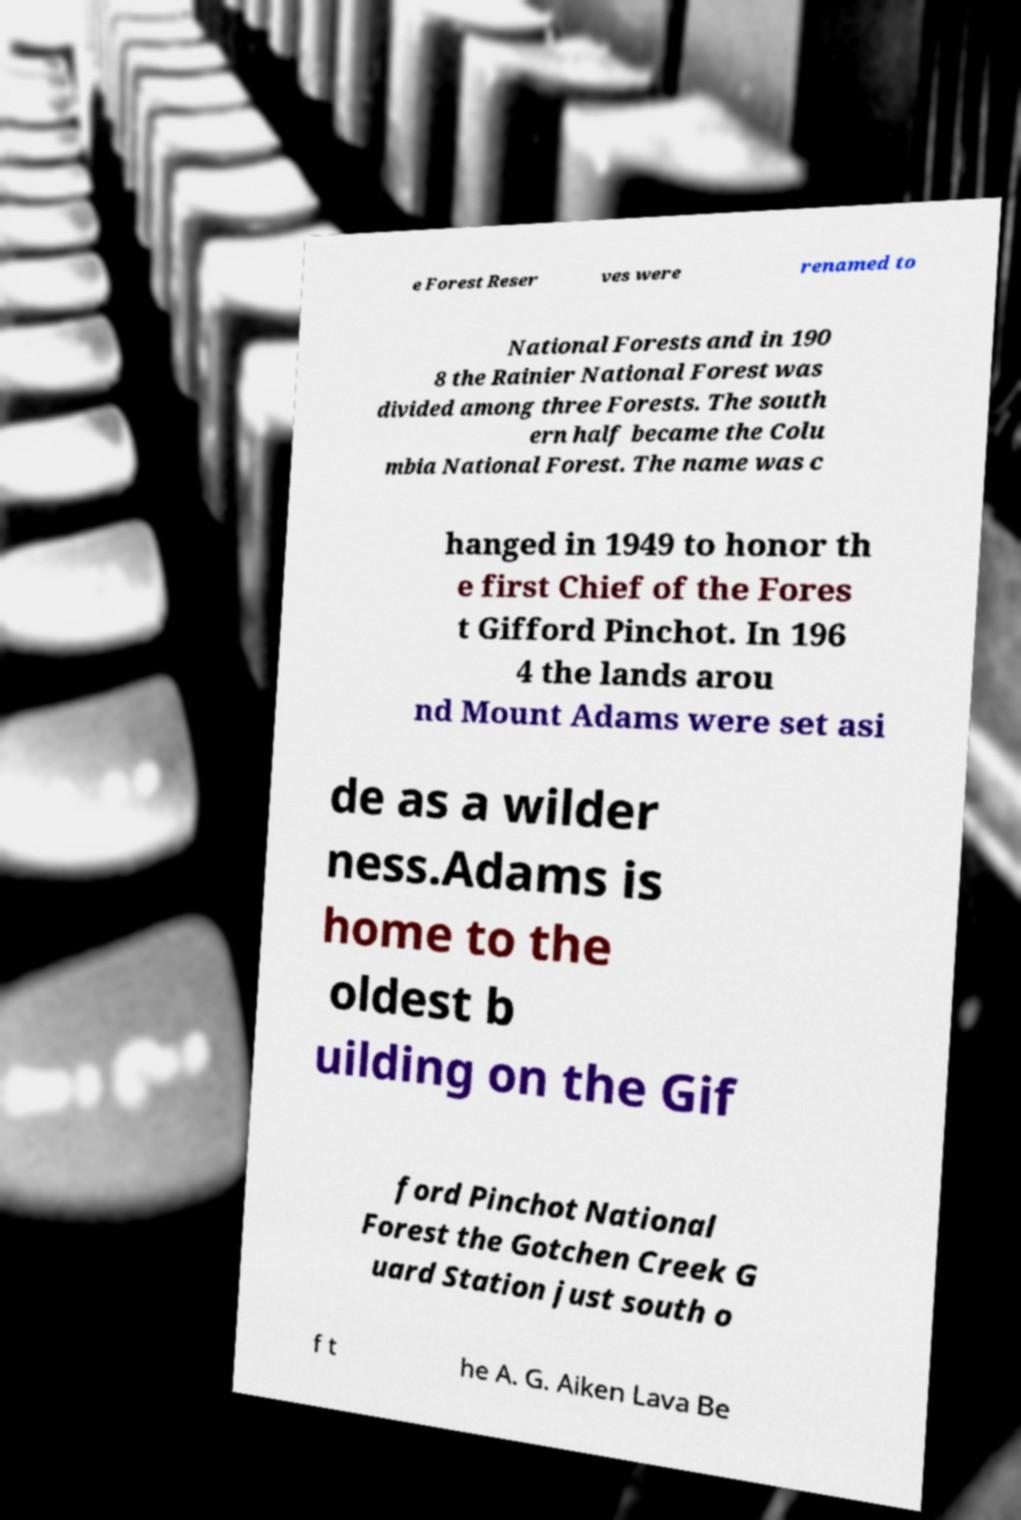What messages or text are displayed in this image? I need them in a readable, typed format. e Forest Reser ves were renamed to National Forests and in 190 8 the Rainier National Forest was divided among three Forests. The south ern half became the Colu mbia National Forest. The name was c hanged in 1949 to honor th e first Chief of the Fores t Gifford Pinchot. In 196 4 the lands arou nd Mount Adams were set asi de as a wilder ness.Adams is home to the oldest b uilding on the Gif ford Pinchot National Forest the Gotchen Creek G uard Station just south o f t he A. G. Aiken Lava Be 